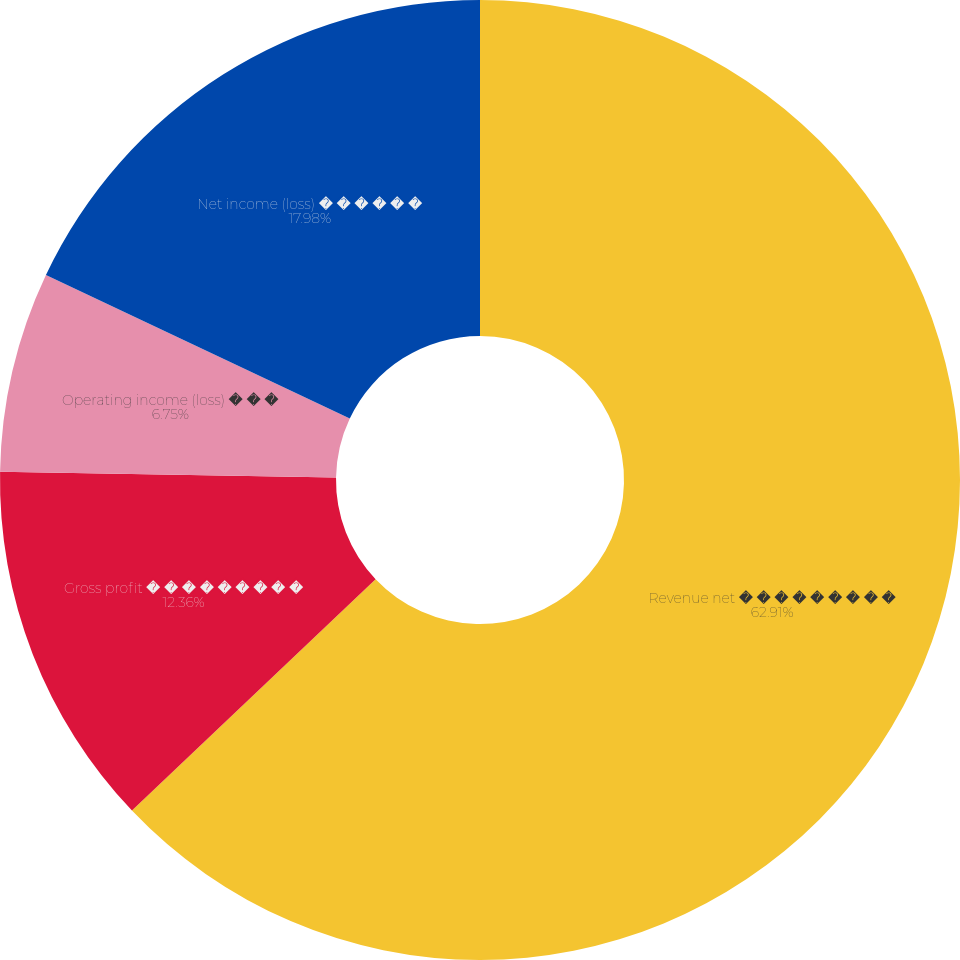Convert chart to OTSL. <chart><loc_0><loc_0><loc_500><loc_500><pie_chart><fcel>Revenue net � � � � � � � � �<fcel>Gross profit � � � � � � � � �<fcel>Operating income (loss) � � �<fcel>Net income (loss) � � � � � �<nl><fcel>62.91%<fcel>12.36%<fcel>6.75%<fcel>17.98%<nl></chart> 